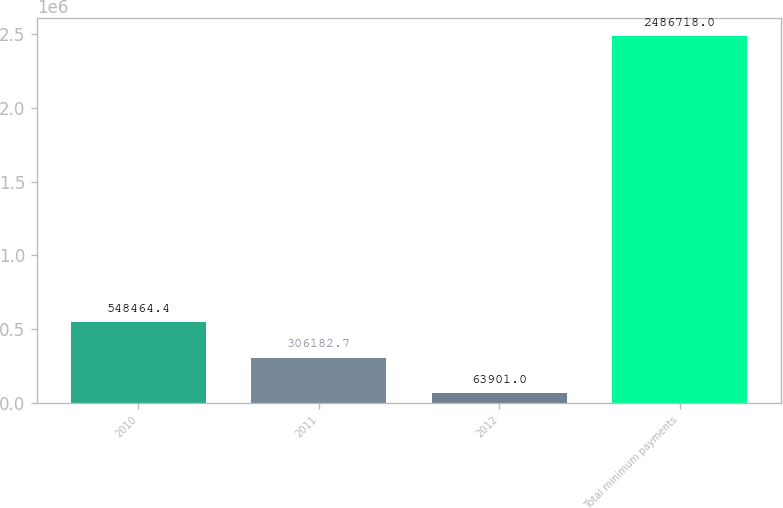Convert chart to OTSL. <chart><loc_0><loc_0><loc_500><loc_500><bar_chart><fcel>2010<fcel>2011<fcel>2012<fcel>Total minimum payments<nl><fcel>548464<fcel>306183<fcel>63901<fcel>2.48672e+06<nl></chart> 